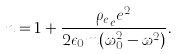<formula> <loc_0><loc_0><loc_500><loc_500>n = 1 + \frac { { \rho _ { e } } _ { e } e ^ { 2 } } { 2 \epsilon _ { 0 } m ( \omega _ { 0 } ^ { 2 } - \omega ^ { 2 } ) } .</formula> 